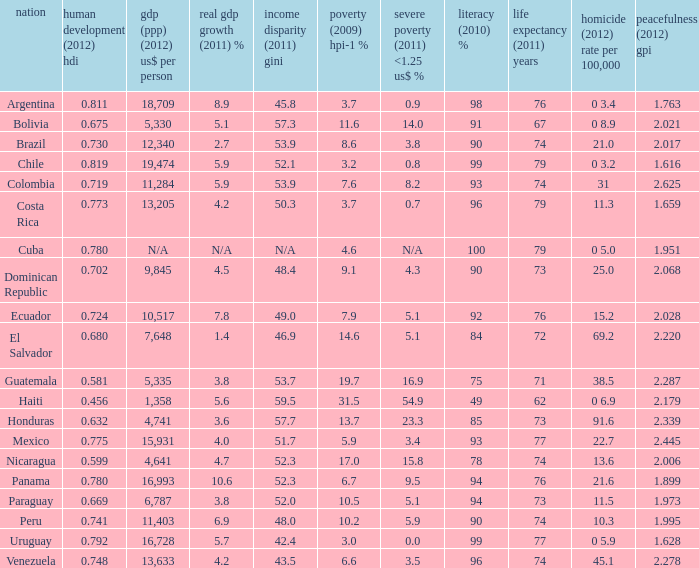What is the sum of poverty (2009) HPI-1 % when the GDP (PPP) (2012) US$ per capita of 11,284? 1.0. Could you parse the entire table as a dict? {'header': ['nation', 'human development (2012) hdi', 'gdp (ppp) (2012) us$ per person', 'real gdp growth (2011) %', 'income disparity (2011) gini', 'poverty (2009) hpi-1 %', 'severe poverty (2011) <1.25 us$ %', 'literacy (2010) %', 'life expectancy (2011) years', 'homicide (2012) rate per 100,000', 'peacefulness (2012) gpi'], 'rows': [['Argentina', '0.811', '18,709', '8.9', '45.8', '3.7', '0.9', '98', '76', '0 3.4', '1.763'], ['Bolivia', '0.675', '5,330', '5.1', '57.3', '11.6', '14.0', '91', '67', '0 8.9', '2.021'], ['Brazil', '0.730', '12,340', '2.7', '53.9', '8.6', '3.8', '90', '74', '21.0', '2.017'], ['Chile', '0.819', '19,474', '5.9', '52.1', '3.2', '0.8', '99', '79', '0 3.2', '1.616'], ['Colombia', '0.719', '11,284', '5.9', '53.9', '7.6', '8.2', '93', '74', '31', '2.625'], ['Costa Rica', '0.773', '13,205', '4.2', '50.3', '3.7', '0.7', '96', '79', '11.3', '1.659'], ['Cuba', '0.780', 'N/A', 'N/A', 'N/A', '4.6', 'N/A', '100', '79', '0 5.0', '1.951'], ['Dominican Republic', '0.702', '9,845', '4.5', '48.4', '9.1', '4.3', '90', '73', '25.0', '2.068'], ['Ecuador', '0.724', '10,517', '7.8', '49.0', '7.9', '5.1', '92', '76', '15.2', '2.028'], ['El Salvador', '0.680', '7,648', '1.4', '46.9', '14.6', '5.1', '84', '72', '69.2', '2.220'], ['Guatemala', '0.581', '5,335', '3.8', '53.7', '19.7', '16.9', '75', '71', '38.5', '2.287'], ['Haiti', '0.456', '1,358', '5.6', '59.5', '31.5', '54.9', '49', '62', '0 6.9', '2.179'], ['Honduras', '0.632', '4,741', '3.6', '57.7', '13.7', '23.3', '85', '73', '91.6', '2.339'], ['Mexico', '0.775', '15,931', '4.0', '51.7', '5.9', '3.4', '93', '77', '22.7', '2.445'], ['Nicaragua', '0.599', '4,641', '4.7', '52.3', '17.0', '15.8', '78', '74', '13.6', '2.006'], ['Panama', '0.780', '16,993', '10.6', '52.3', '6.7', '9.5', '94', '76', '21.6', '1.899'], ['Paraguay', '0.669', '6,787', '3.8', '52.0', '10.5', '5.1', '94', '73', '11.5', '1.973'], ['Peru', '0.741', '11,403', '6.9', '48.0', '10.2', '5.9', '90', '74', '10.3', '1.995'], ['Uruguay', '0.792', '16,728', '5.7', '42.4', '3.0', '0.0', '99', '77', '0 5.9', '1.628'], ['Venezuela', '0.748', '13,633', '4.2', '43.5', '6.6', '3.5', '96', '74', '45.1', '2.278']]} 